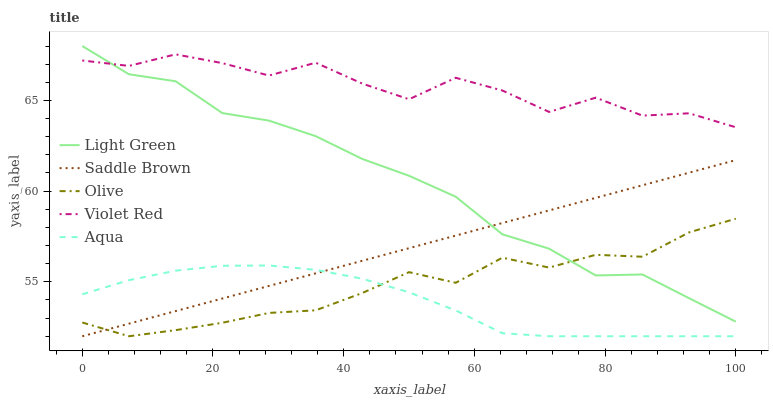Does Aqua have the minimum area under the curve?
Answer yes or no. Yes. Does Violet Red have the maximum area under the curve?
Answer yes or no. Yes. Does Violet Red have the minimum area under the curve?
Answer yes or no. No. Does Aqua have the maximum area under the curve?
Answer yes or no. No. Is Saddle Brown the smoothest?
Answer yes or no. Yes. Is Violet Red the roughest?
Answer yes or no. Yes. Is Aqua the smoothest?
Answer yes or no. No. Is Aqua the roughest?
Answer yes or no. No. Does Olive have the lowest value?
Answer yes or no. Yes. Does Violet Red have the lowest value?
Answer yes or no. No. Does Light Green have the highest value?
Answer yes or no. Yes. Does Violet Red have the highest value?
Answer yes or no. No. Is Saddle Brown less than Violet Red?
Answer yes or no. Yes. Is Violet Red greater than Olive?
Answer yes or no. Yes. Does Saddle Brown intersect Light Green?
Answer yes or no. Yes. Is Saddle Brown less than Light Green?
Answer yes or no. No. Is Saddle Brown greater than Light Green?
Answer yes or no. No. Does Saddle Brown intersect Violet Red?
Answer yes or no. No. 